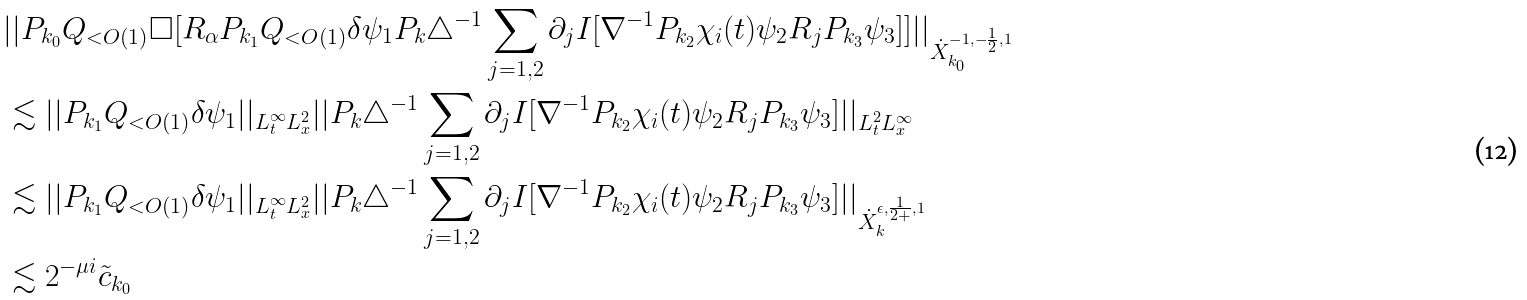Convert formula to latex. <formula><loc_0><loc_0><loc_500><loc_500>& | | P _ { k _ { 0 } } Q _ { < O ( 1 ) } \Box [ R _ { \alpha } P _ { k _ { 1 } } Q _ { < O ( 1 ) } \delta \psi _ { 1 } P _ { k } \triangle ^ { - 1 } \sum _ { j = 1 , 2 } \partial _ { j } I [ \nabla ^ { - 1 } P _ { k _ { 2 } } \chi _ { i } ( t ) \psi _ { 2 } R _ { j } P _ { k _ { 3 } } \psi _ { 3 } ] ] | | _ { \dot { X } _ { k _ { 0 } } ^ { - 1 , - \frac { 1 } { 2 } , 1 } } \\ & \lesssim | | P _ { k _ { 1 } } Q _ { < O ( 1 ) } \delta \psi _ { 1 } | | _ { L _ { t } ^ { \infty } L _ { x } ^ { 2 } } | | P _ { k } \triangle ^ { - 1 } \sum _ { j = 1 , 2 } \partial _ { j } I [ \nabla ^ { - 1 } P _ { k _ { 2 } } \chi _ { i } ( t ) \psi _ { 2 } R _ { j } P _ { k _ { 3 } } \psi _ { 3 } ] | | _ { L _ { t } ^ { 2 } L _ { x } ^ { \infty } } \\ & \lesssim | | P _ { k _ { 1 } } Q _ { < O ( 1 ) } \delta \psi _ { 1 } | | _ { L _ { t } ^ { \infty } L _ { x } ^ { 2 } } | | P _ { k } \triangle ^ { - 1 } \sum _ { j = 1 , 2 } \partial _ { j } I [ \nabla ^ { - 1 } P _ { k _ { 2 } } \chi _ { i } ( t ) \psi _ { 2 } R _ { j } P _ { k _ { 3 } } \psi _ { 3 } ] | | _ { \dot { X } _ { k } ^ { \epsilon , \frac { 1 } { 2 + } , 1 } } \\ & \lesssim 2 ^ { - \mu i } \tilde { c } _ { k _ { 0 } } \\</formula> 